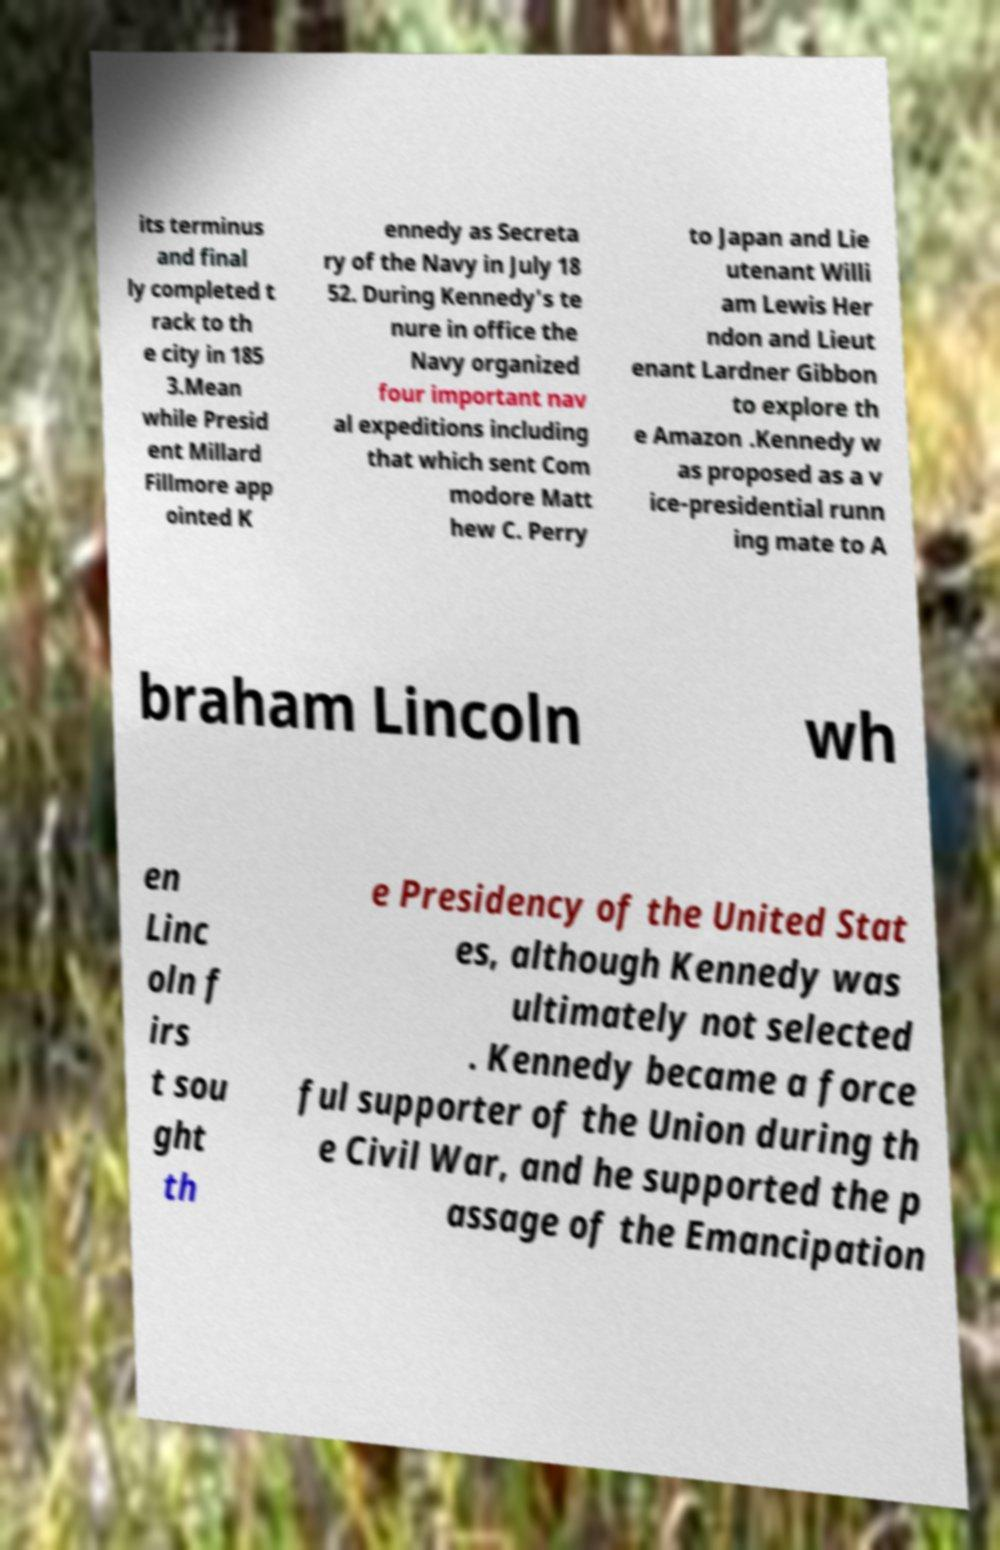What messages or text are displayed in this image? I need them in a readable, typed format. its terminus and final ly completed t rack to th e city in 185 3.Mean while Presid ent Millard Fillmore app ointed K ennedy as Secreta ry of the Navy in July 18 52. During Kennedy's te nure in office the Navy organized four important nav al expeditions including that which sent Com modore Matt hew C. Perry to Japan and Lie utenant Willi am Lewis Her ndon and Lieut enant Lardner Gibbon to explore th e Amazon .Kennedy w as proposed as a v ice-presidential runn ing mate to A braham Lincoln wh en Linc oln f irs t sou ght th e Presidency of the United Stat es, although Kennedy was ultimately not selected . Kennedy became a force ful supporter of the Union during th e Civil War, and he supported the p assage of the Emancipation 